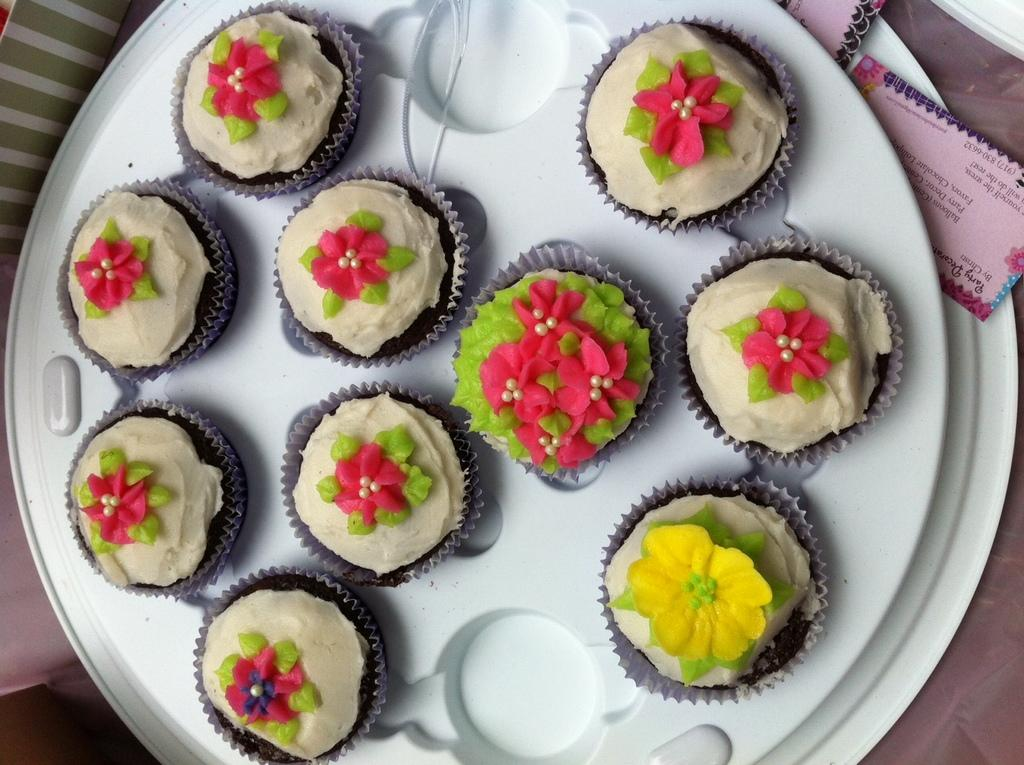What type of food is visible on the tray in the image? There are muffins placed on a tray in the image. What else can be seen in the background of the image? There are visiting cards in the background of the image. What type of boats can be seen in the harbor in the image? There is no harbor or boats present in the image; it only features muffins on a tray and visiting cards in the background. 